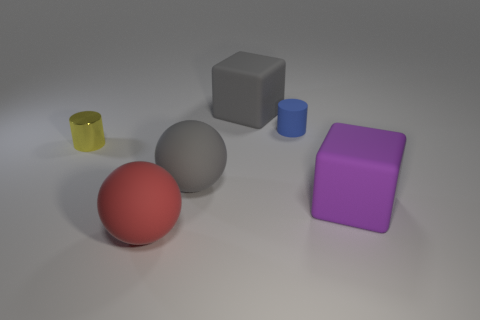There is another rubber object that is the same shape as the red rubber thing; what is its color?
Your response must be concise. Gray. What number of metallic objects are small yellow cylinders or small cylinders?
Your response must be concise. 1. There is a gray object that is in front of the small blue object to the right of the yellow thing; are there any gray matte objects that are to the right of it?
Keep it short and to the point. Yes. What color is the tiny metallic object?
Your answer should be very brief. Yellow. Does the yellow shiny thing that is behind the big red thing have the same shape as the big purple thing?
Your answer should be compact. No. How many things are either purple matte things or large rubber things that are behind the red sphere?
Provide a short and direct response. 3. Is the material of the cube on the left side of the tiny blue cylinder the same as the yellow cylinder?
Your answer should be compact. No. The cube in front of the block that is behind the small yellow shiny object is made of what material?
Ensure brevity in your answer.  Rubber. Are there more big matte things that are right of the tiny yellow object than big balls in front of the gray block?
Ensure brevity in your answer.  Yes. What size is the metallic cylinder?
Give a very brief answer. Small. 